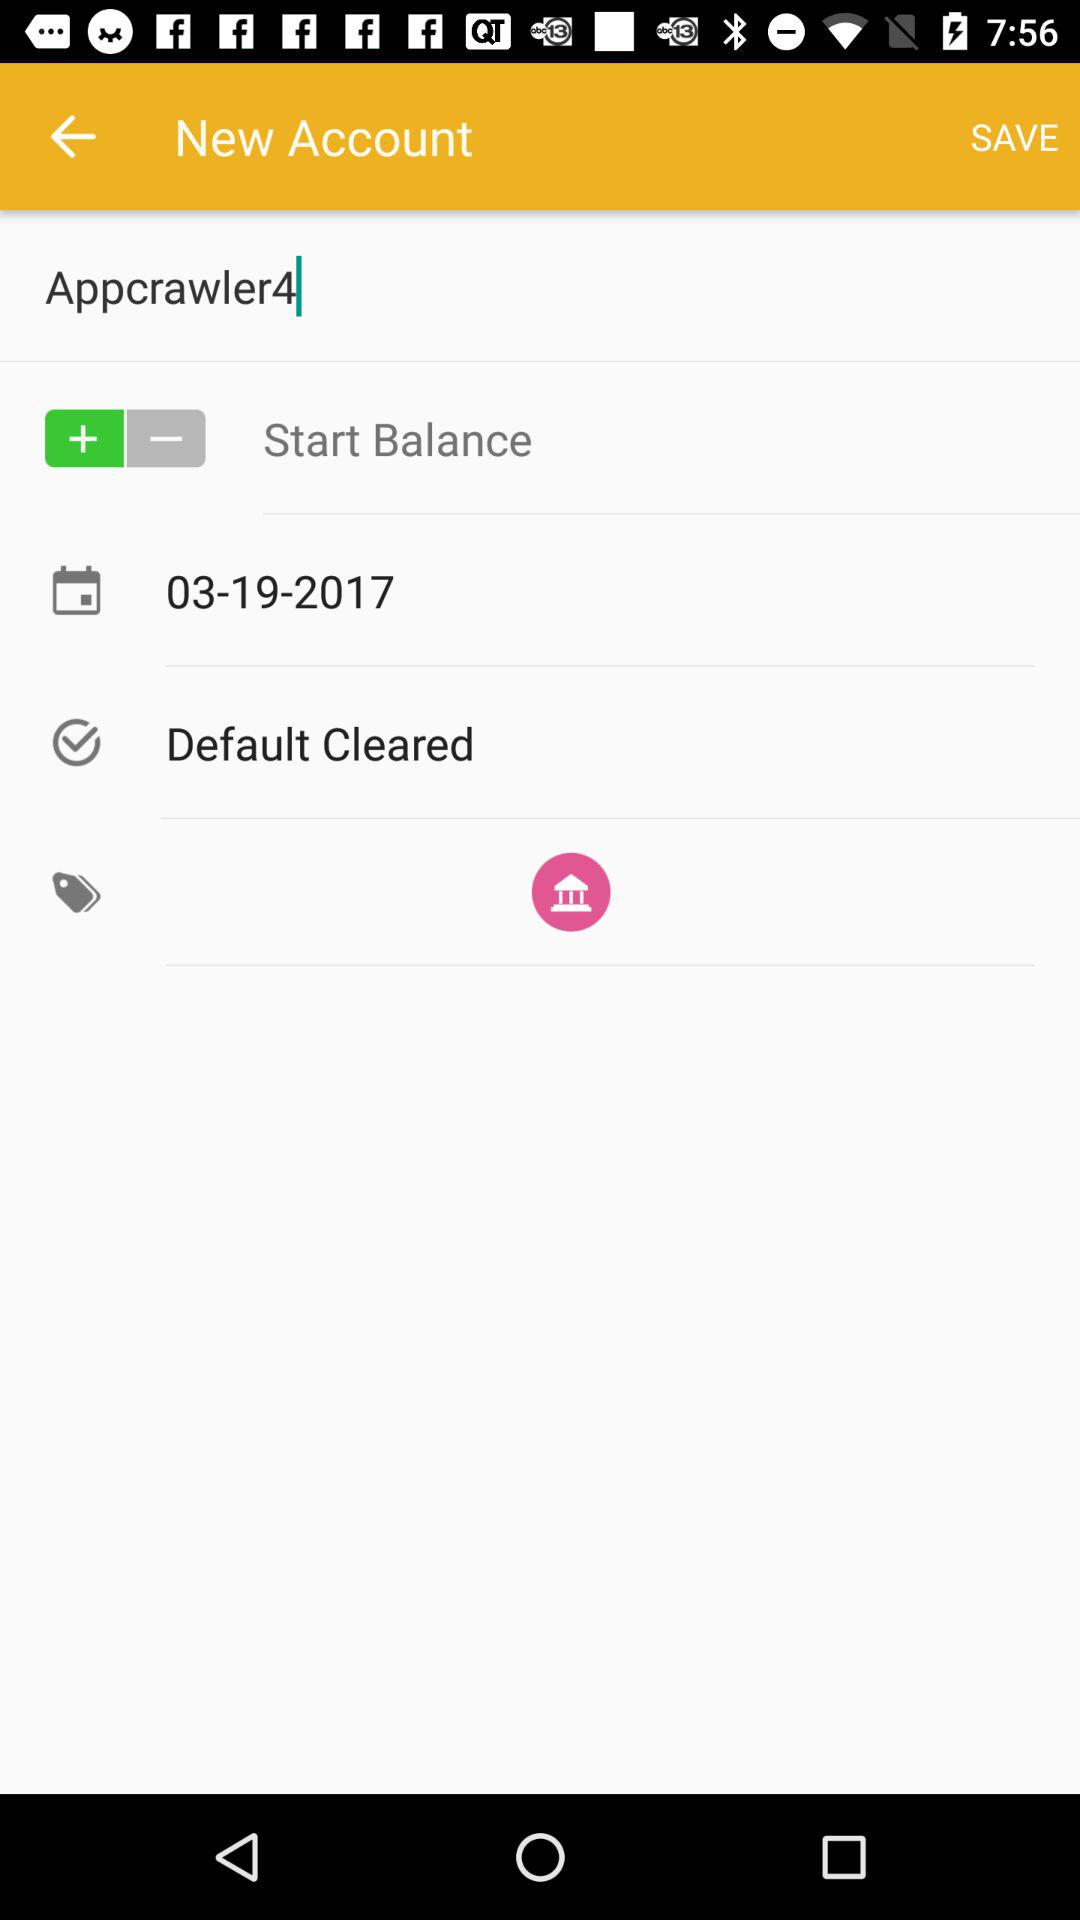How many items have a text value?
Answer the question using a single word or phrase. 4 